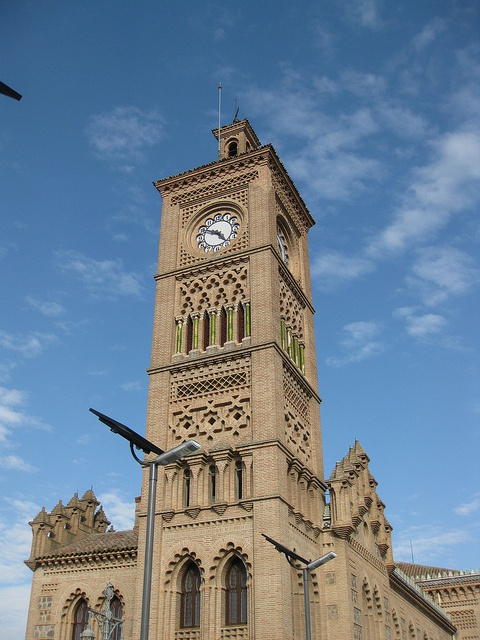Describe the objects in this image and their specific colors. I can see clock in blue, lightgray, gray, tan, and darkgray tones and clock in blue, gray, darkgray, black, and lightgray tones in this image. 